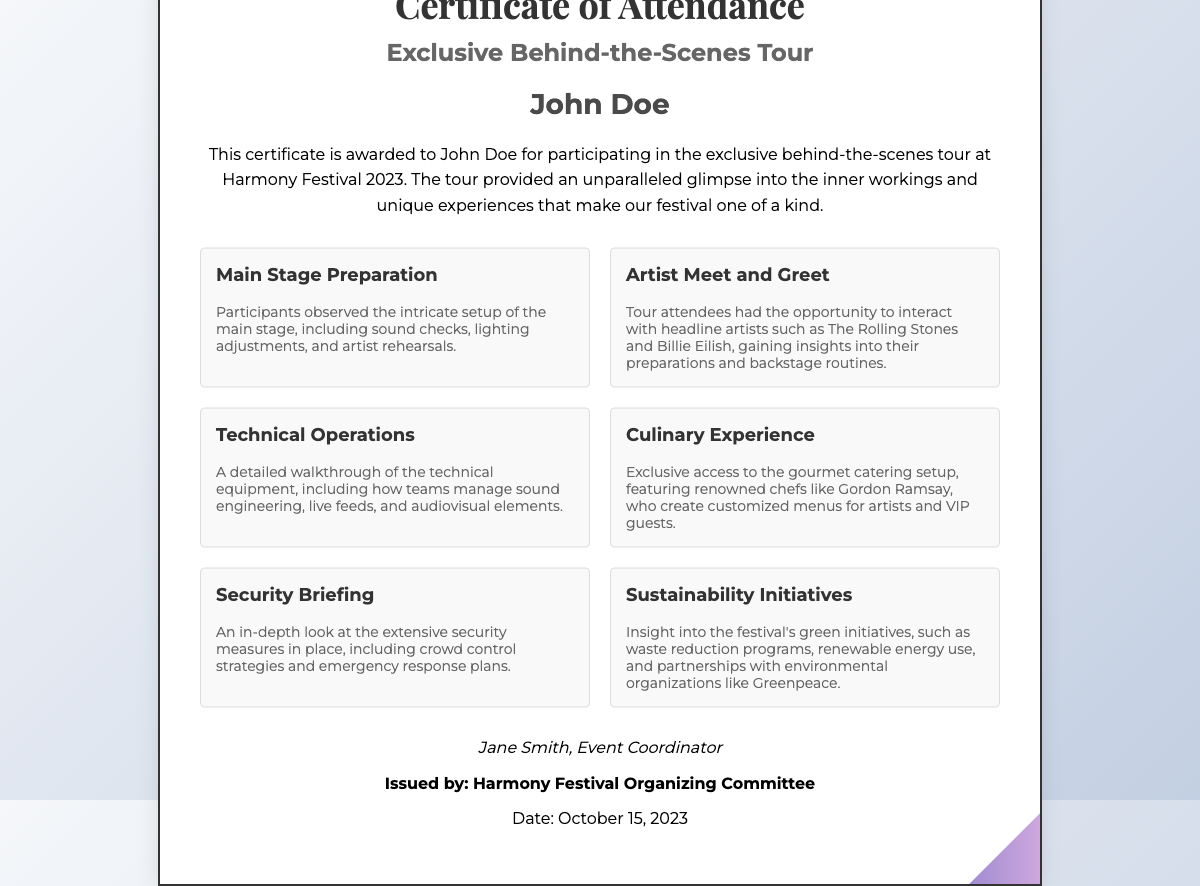What is the title of the event? The title of the event is prominently featured at the top of the certificate, indicating the purpose of the attendance certificate.
Answer: Exclusive Behind-the-Scenes Tour Who is the participant? The participant's name is displayed prominently in the document as the recipient of the certificate.
Answer: John Doe What is the date of the event? The date is listed at the bottom of the certificate, providing a clear reference for when the tour took place.
Answer: October 15, 2023 Who issued the certificate? The issuer's name is mentioned at the bottom, indicating the authority responsible for providing the certificate.
Answer: Harmony Festival Organizing Committee How many highlights are listed in the document? The number of highlights can be determined by counting the sections provided in the highlights area.
Answer: Six What was one of the main stage preparation activities? The document describes activities related to the main stage preparation highlighting what participants experienced during the tour.
Answer: Sound checks What culinary feature was included in the tour? The document highlights a specific aspect of the culinary experience that was part of the tour, showcasing the unique offering.
Answer: Gourmet catering setup What is the name of the event coordinator? The event coordinator's name is mentioned alongside their signature, providing recognition for their role in the event.
Answer: Jane Smith What organization is mentioned as a partner in sustainability initiatives? The document lists an organization collaborating with the festival on its sustainability efforts.
Answer: Greenpeace 